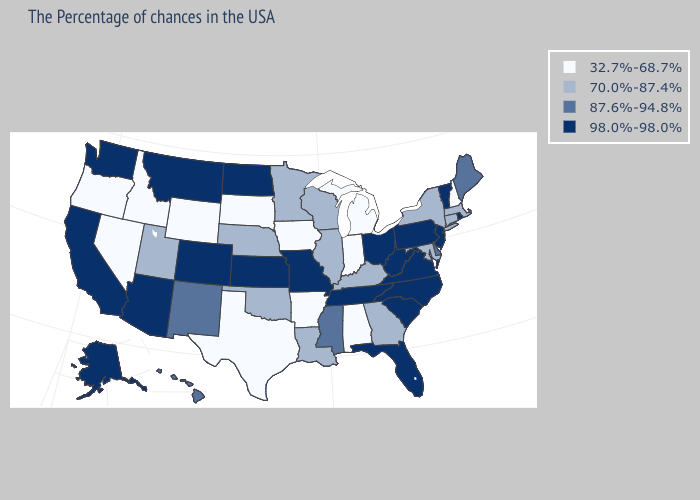What is the value of Wyoming?
Keep it brief. 32.7%-68.7%. Name the states that have a value in the range 98.0%-98.0%?
Concise answer only. Rhode Island, Vermont, New Jersey, Pennsylvania, Virginia, North Carolina, South Carolina, West Virginia, Ohio, Florida, Tennessee, Missouri, Kansas, North Dakota, Colorado, Montana, Arizona, California, Washington, Alaska. What is the value of Georgia?
Quick response, please. 70.0%-87.4%. What is the value of Texas?
Concise answer only. 32.7%-68.7%. What is the highest value in states that border Oregon?
Answer briefly. 98.0%-98.0%. Name the states that have a value in the range 70.0%-87.4%?
Give a very brief answer. Massachusetts, Connecticut, New York, Maryland, Georgia, Kentucky, Wisconsin, Illinois, Louisiana, Minnesota, Nebraska, Oklahoma, Utah. Name the states that have a value in the range 32.7%-68.7%?
Quick response, please. New Hampshire, Michigan, Indiana, Alabama, Arkansas, Iowa, Texas, South Dakota, Wyoming, Idaho, Nevada, Oregon. Among the states that border Nevada , does Utah have the highest value?
Answer briefly. No. Which states hav the highest value in the West?
Be succinct. Colorado, Montana, Arizona, California, Washington, Alaska. What is the value of Utah?
Write a very short answer. 70.0%-87.4%. What is the highest value in the USA?
Short answer required. 98.0%-98.0%. Name the states that have a value in the range 98.0%-98.0%?
Write a very short answer. Rhode Island, Vermont, New Jersey, Pennsylvania, Virginia, North Carolina, South Carolina, West Virginia, Ohio, Florida, Tennessee, Missouri, Kansas, North Dakota, Colorado, Montana, Arizona, California, Washington, Alaska. Name the states that have a value in the range 98.0%-98.0%?
Short answer required. Rhode Island, Vermont, New Jersey, Pennsylvania, Virginia, North Carolina, South Carolina, West Virginia, Ohio, Florida, Tennessee, Missouri, Kansas, North Dakota, Colorado, Montana, Arizona, California, Washington, Alaska. What is the lowest value in the USA?
Keep it brief. 32.7%-68.7%. What is the lowest value in states that border Florida?
Answer briefly. 32.7%-68.7%. 